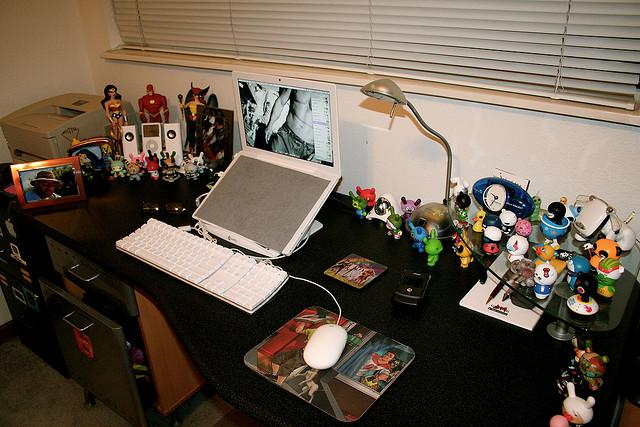Which female superhero is on the left corner of the desk?

Choices:
A) black widow
B) she hulk
C) wonder woman
D) harley quinn wonder woman 